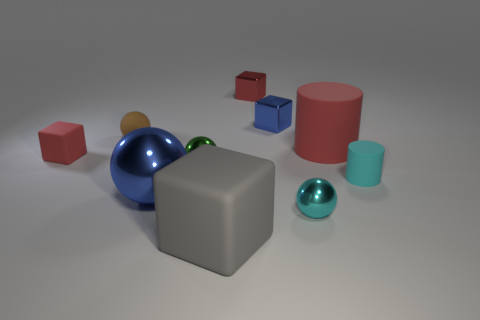Subtract all cylinders. How many objects are left? 8 Add 2 large purple matte things. How many large purple matte things exist? 2 Subtract 1 blue balls. How many objects are left? 9 Subtract all red rubber objects. Subtract all red rubber objects. How many objects are left? 6 Add 6 cyan matte things. How many cyan matte things are left? 7 